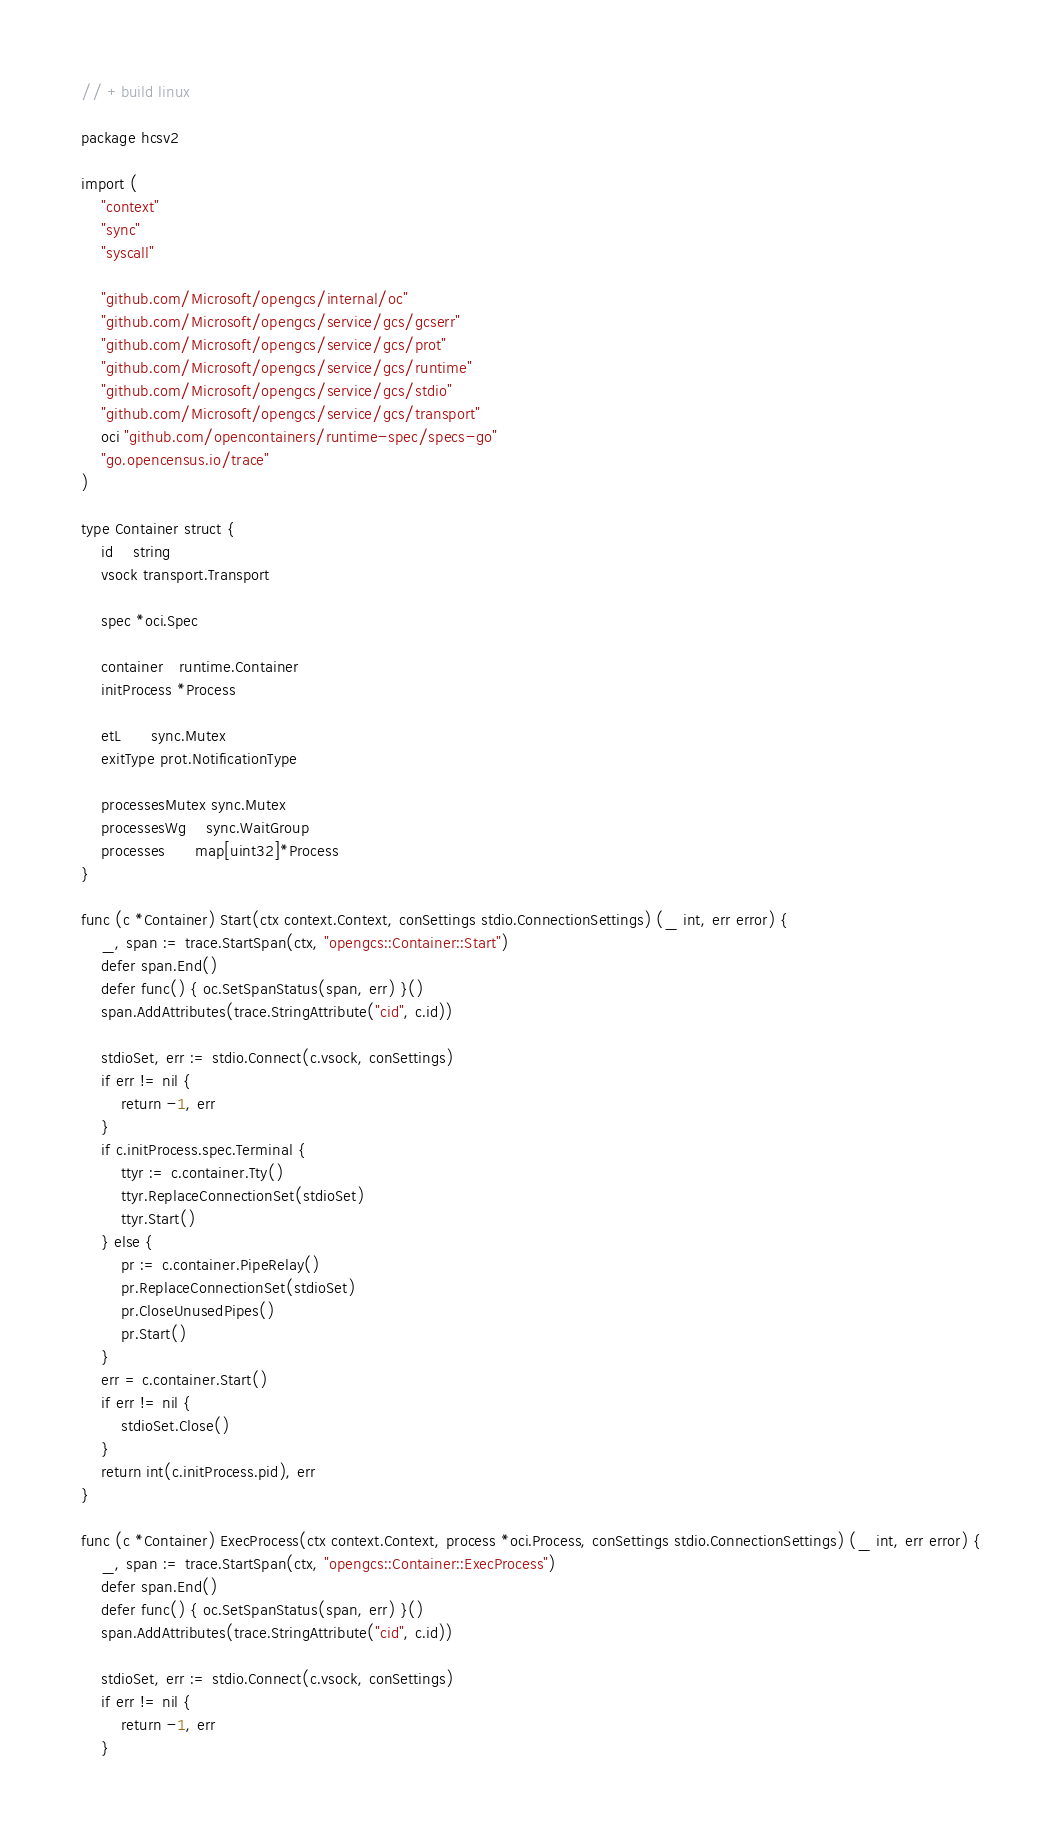<code> <loc_0><loc_0><loc_500><loc_500><_Go_>// +build linux

package hcsv2

import (
	"context"
	"sync"
	"syscall"

	"github.com/Microsoft/opengcs/internal/oc"
	"github.com/Microsoft/opengcs/service/gcs/gcserr"
	"github.com/Microsoft/opengcs/service/gcs/prot"
	"github.com/Microsoft/opengcs/service/gcs/runtime"
	"github.com/Microsoft/opengcs/service/gcs/stdio"
	"github.com/Microsoft/opengcs/service/gcs/transport"
	oci "github.com/opencontainers/runtime-spec/specs-go"
	"go.opencensus.io/trace"
)

type Container struct {
	id    string
	vsock transport.Transport

	spec *oci.Spec

	container   runtime.Container
	initProcess *Process

	etL      sync.Mutex
	exitType prot.NotificationType

	processesMutex sync.Mutex
	processesWg    sync.WaitGroup
	processes      map[uint32]*Process
}

func (c *Container) Start(ctx context.Context, conSettings stdio.ConnectionSettings) (_ int, err error) {
	_, span := trace.StartSpan(ctx, "opengcs::Container::Start")
	defer span.End()
	defer func() { oc.SetSpanStatus(span, err) }()
	span.AddAttributes(trace.StringAttribute("cid", c.id))

	stdioSet, err := stdio.Connect(c.vsock, conSettings)
	if err != nil {
		return -1, err
	}
	if c.initProcess.spec.Terminal {
		ttyr := c.container.Tty()
		ttyr.ReplaceConnectionSet(stdioSet)
		ttyr.Start()
	} else {
		pr := c.container.PipeRelay()
		pr.ReplaceConnectionSet(stdioSet)
		pr.CloseUnusedPipes()
		pr.Start()
	}
	err = c.container.Start()
	if err != nil {
		stdioSet.Close()
	}
	return int(c.initProcess.pid), err
}

func (c *Container) ExecProcess(ctx context.Context, process *oci.Process, conSettings stdio.ConnectionSettings) (_ int, err error) {
	_, span := trace.StartSpan(ctx, "opengcs::Container::ExecProcess")
	defer span.End()
	defer func() { oc.SetSpanStatus(span, err) }()
	span.AddAttributes(trace.StringAttribute("cid", c.id))

	stdioSet, err := stdio.Connect(c.vsock, conSettings)
	if err != nil {
		return -1, err
	}
</code> 